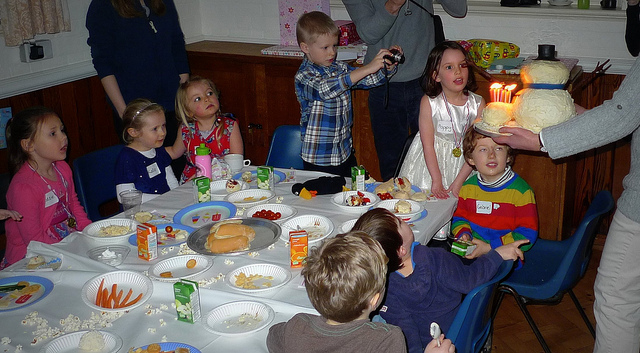Please identify all text content in this image. &amp; 